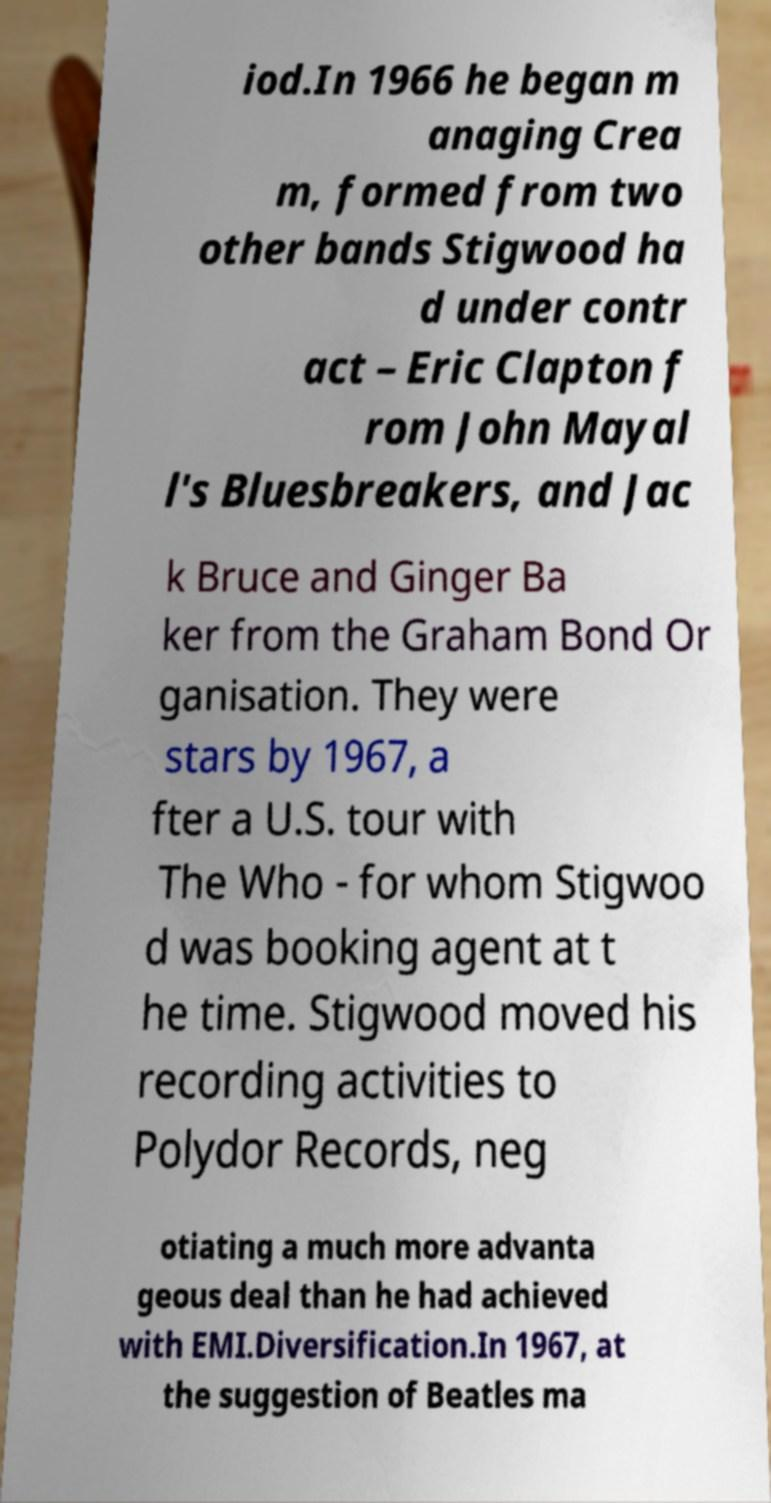Please identify and transcribe the text found in this image. iod.In 1966 he began m anaging Crea m, formed from two other bands Stigwood ha d under contr act – Eric Clapton f rom John Mayal l's Bluesbreakers, and Jac k Bruce and Ginger Ba ker from the Graham Bond Or ganisation. They were stars by 1967, a fter a U.S. tour with The Who - for whom Stigwoo d was booking agent at t he time. Stigwood moved his recording activities to Polydor Records, neg otiating a much more advanta geous deal than he had achieved with EMI.Diversification.In 1967, at the suggestion of Beatles ma 